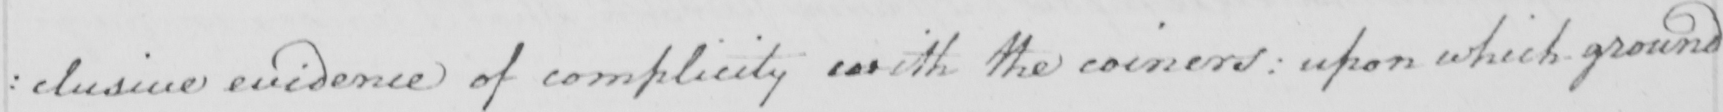Transcribe the text shown in this historical manuscript line. : clusive evidence of complicity with the coiners :  upon which ground 